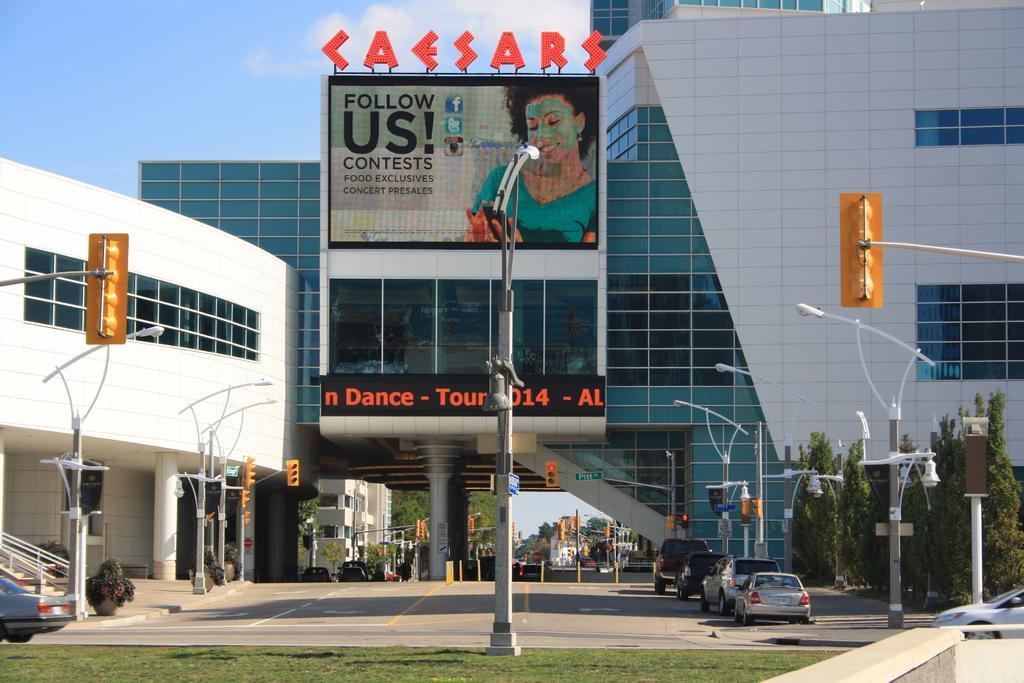Could you give a brief overview of what you see in this image? As we can see in the image there are buildings, street lamps, grass, banner, trees, cars, stars and sky. 